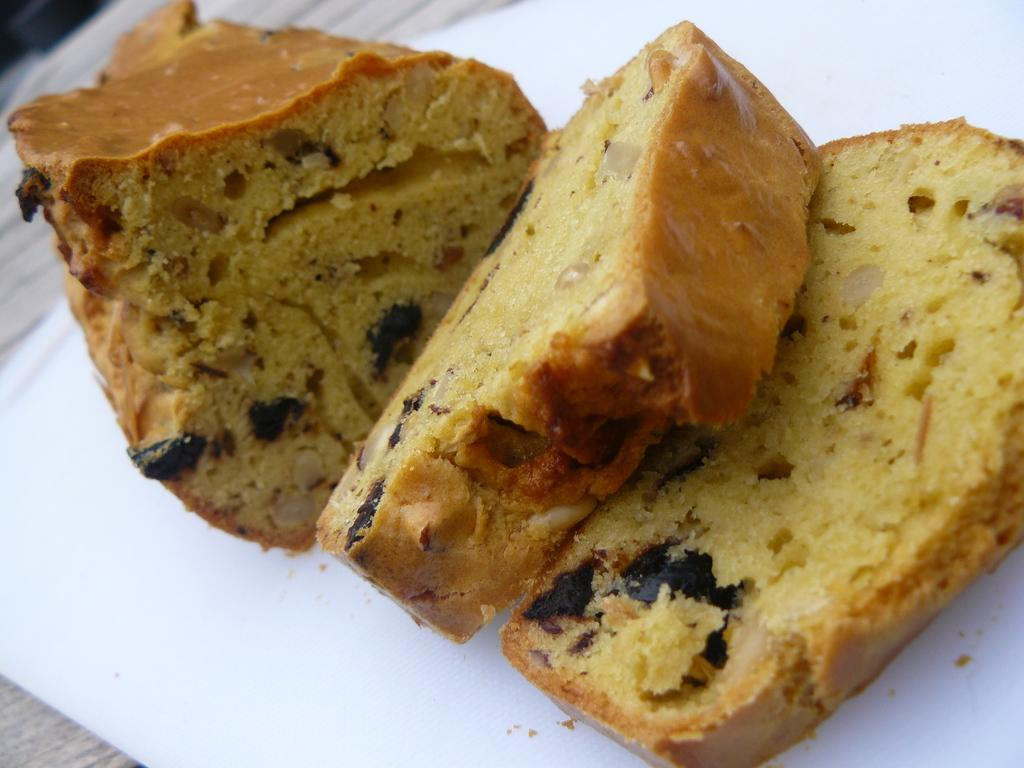What type of food is visible in the image? The food appears to be cake slices in the image. What color is the background of the image? The background of the image is white. How many pets are interacting with the cake slices in the image? There are no pets present in the image, so it is not possible to determine how they might interact with the cake slices. 